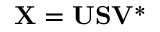Convert formula to latex. <formula><loc_0><loc_0><loc_500><loc_500>X = U S V ^ { * }</formula> 